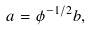Convert formula to latex. <formula><loc_0><loc_0><loc_500><loc_500>a = \phi ^ { - 1 / 2 } b ,</formula> 